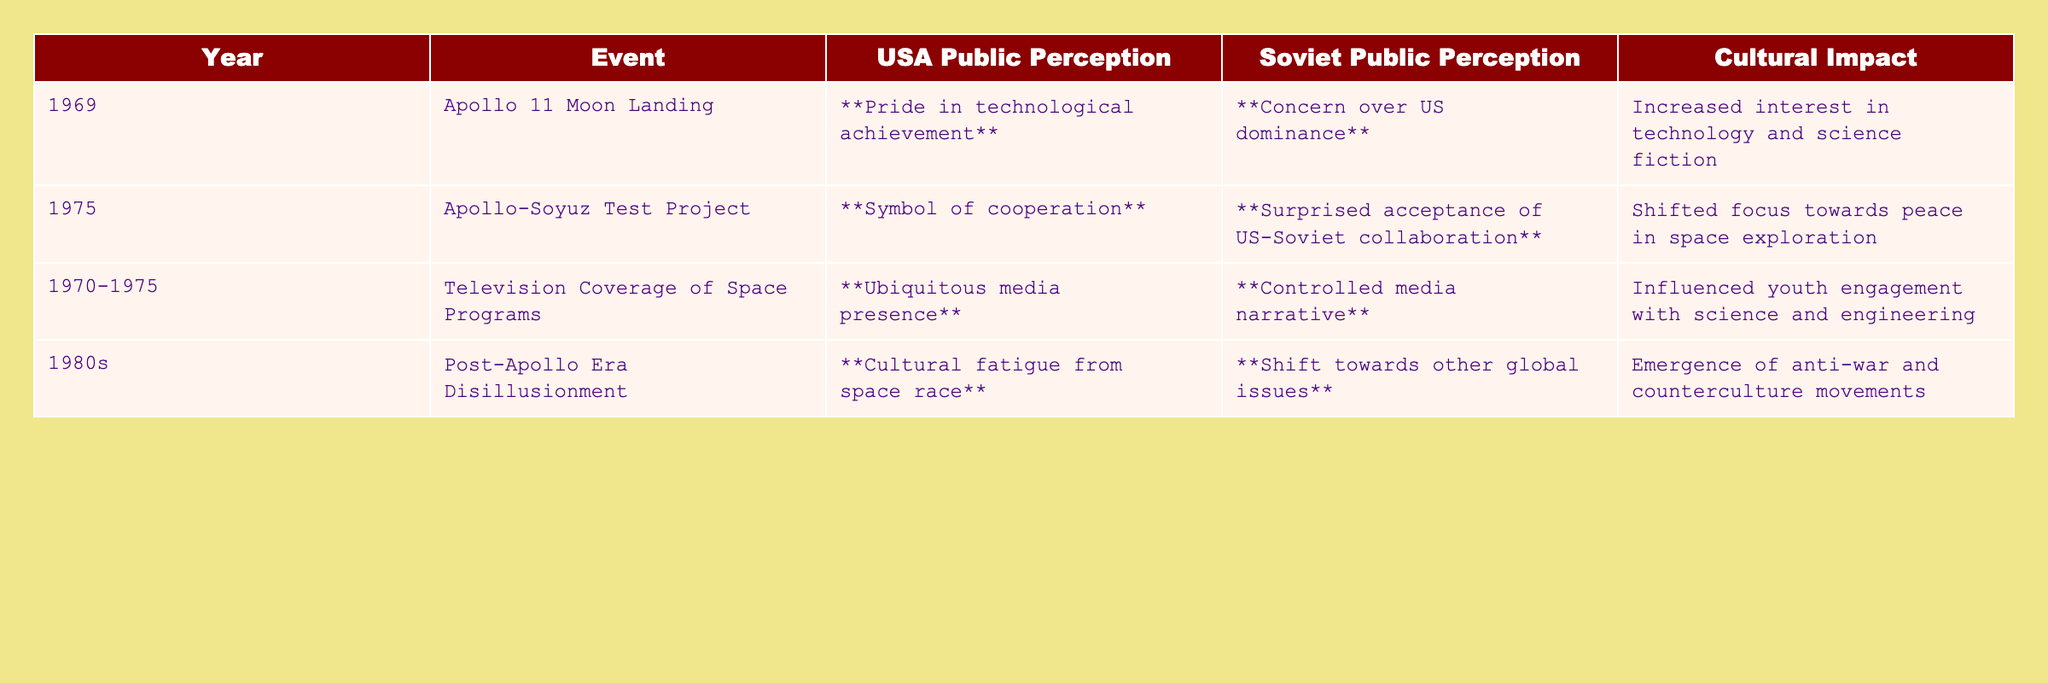What was the public perception in the USA during the Apollo 11 Moon Landing? The table indicates that public perception in the USA at that time was "Pride in technological achievement."
Answer: Pride in technological achievement What cultural impact was observed after the Apollo-Soyuz Test Project? The cultural impact listed is "Shifted focus towards peace in space exploration."
Answer: Shifted focus towards peace in space exploration Was there media coverage of space programs in both the USA and the Soviet Union during 1970-1975? Yes, the USA had "Ubiquitous media presence," while the Soviet Union had a "Controlled media narrative."
Answer: Yes What was the primary concern of the Soviet public regarding the Apollo 11 Moon Landing? The table states the concern was "Concern over US dominance."
Answer: Concern over US dominance In what decade did both nations experience disillusionment regarding space exploration? The table indicates that this occurred in the 1980s.
Answer: 1980s What is the difference in cultural impact between the Apollo 11 Moon Landing and the Apollo-Soyuz Test Project? The Apollo 11 Moon Landing led to "Increased interest in technology and science fiction," while the Apollo-Soyuz Test Project contributed to a "Shifted focus towards peace in space exploration."
Answer: Increased interest vs. shifted focus Did the Apollo 11 Moon Landing have a positive or negative cultural impact in the USA according to the table? The impact was positive, as it increased interest in technology and science fiction.
Answer: Positive impact What feelings did the Soviet Union experience during the Apollo-Soyuz Test Project? The Soviet public experienced "Surprised acceptance of US-Soviet collaboration."
Answer: Surprised acceptance Overall, how did the cultural impact of the Apollo program compare to that of the Soyuz program in the USA? The Apollo program resulted in a sense of pride and interest in technology, while the Soyuz program emphasized cooperation and peace.
Answer: Apollo: pride; Soyuz: cooperation Which event marked a significant shift towards collaboration between the USA and the Soviet Union? The Apollo-Soyuz Test Project marked this shift.
Answer: Apollo-Soyuz Test Project 